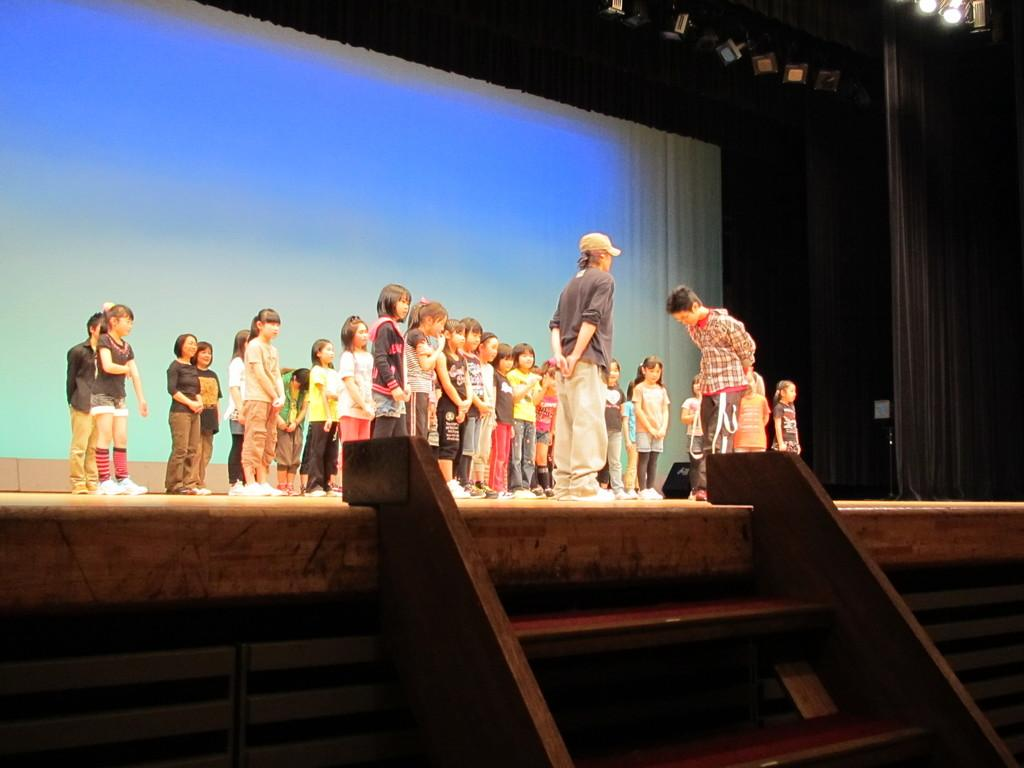What is the main subject of the image? The main subject of the image is a group of children. Are there any adults present in the image? Yes, there are two persons standing in the image. What can be seen in the background of the image? Stars are visible in the image. What might be the focus of attention in the image? There is a light focus towards a stage in the image. What type of teaching method is being demonstrated by the sink in the image? There is no sink present in the image, so it is not possible to determine any teaching methods related to it. 